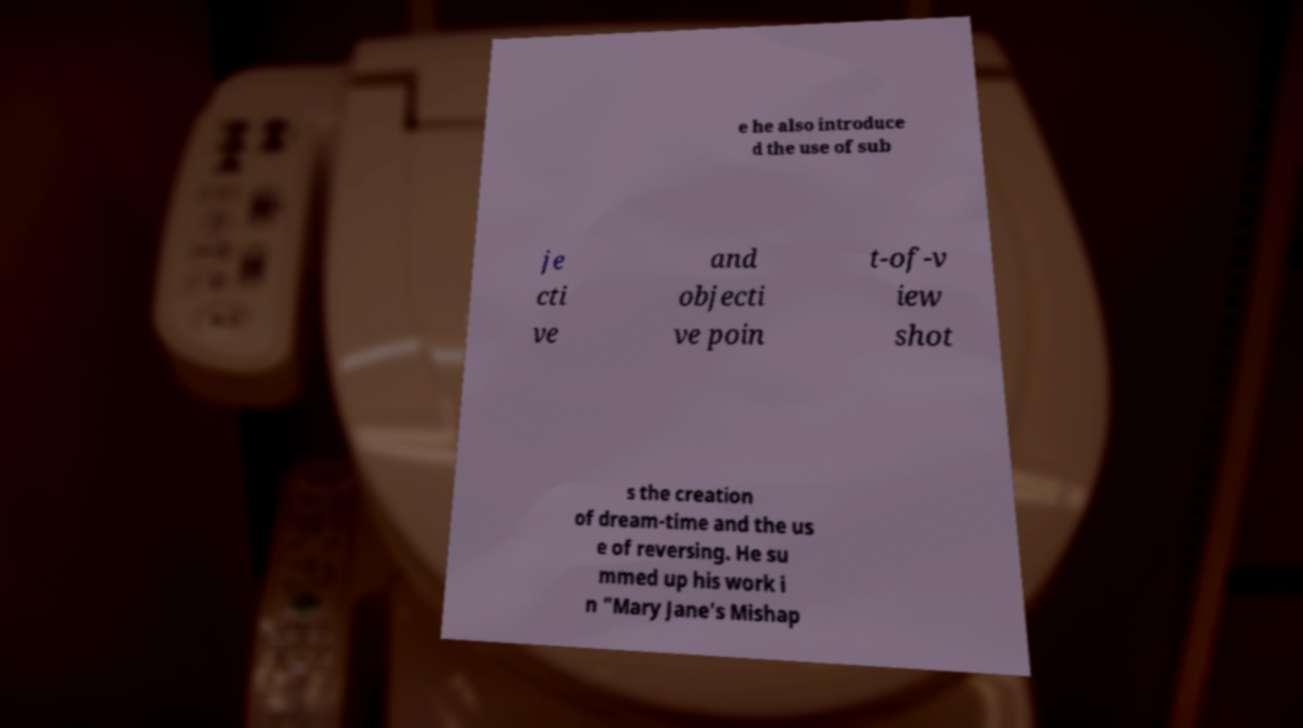What messages or text are displayed in this image? I need them in a readable, typed format. e he also introduce d the use of sub je cti ve and objecti ve poin t-of-v iew shot s the creation of dream-time and the us e of reversing. He su mmed up his work i n "Mary Jane's Mishap 